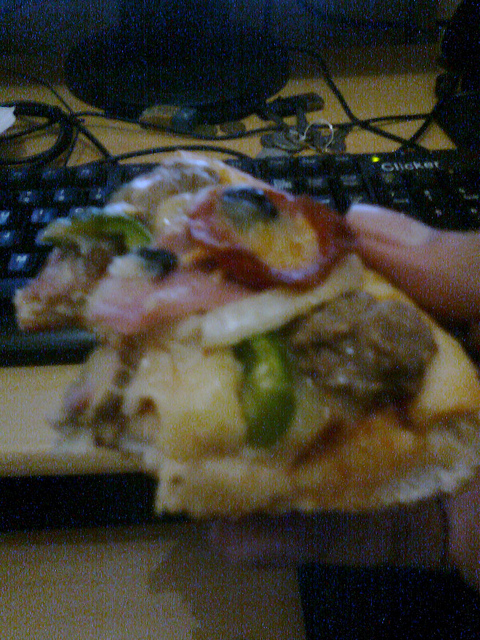Can you identify the types of meats on this pizza? The pizza appears to include ham and possibly some salami or other processed meats. 